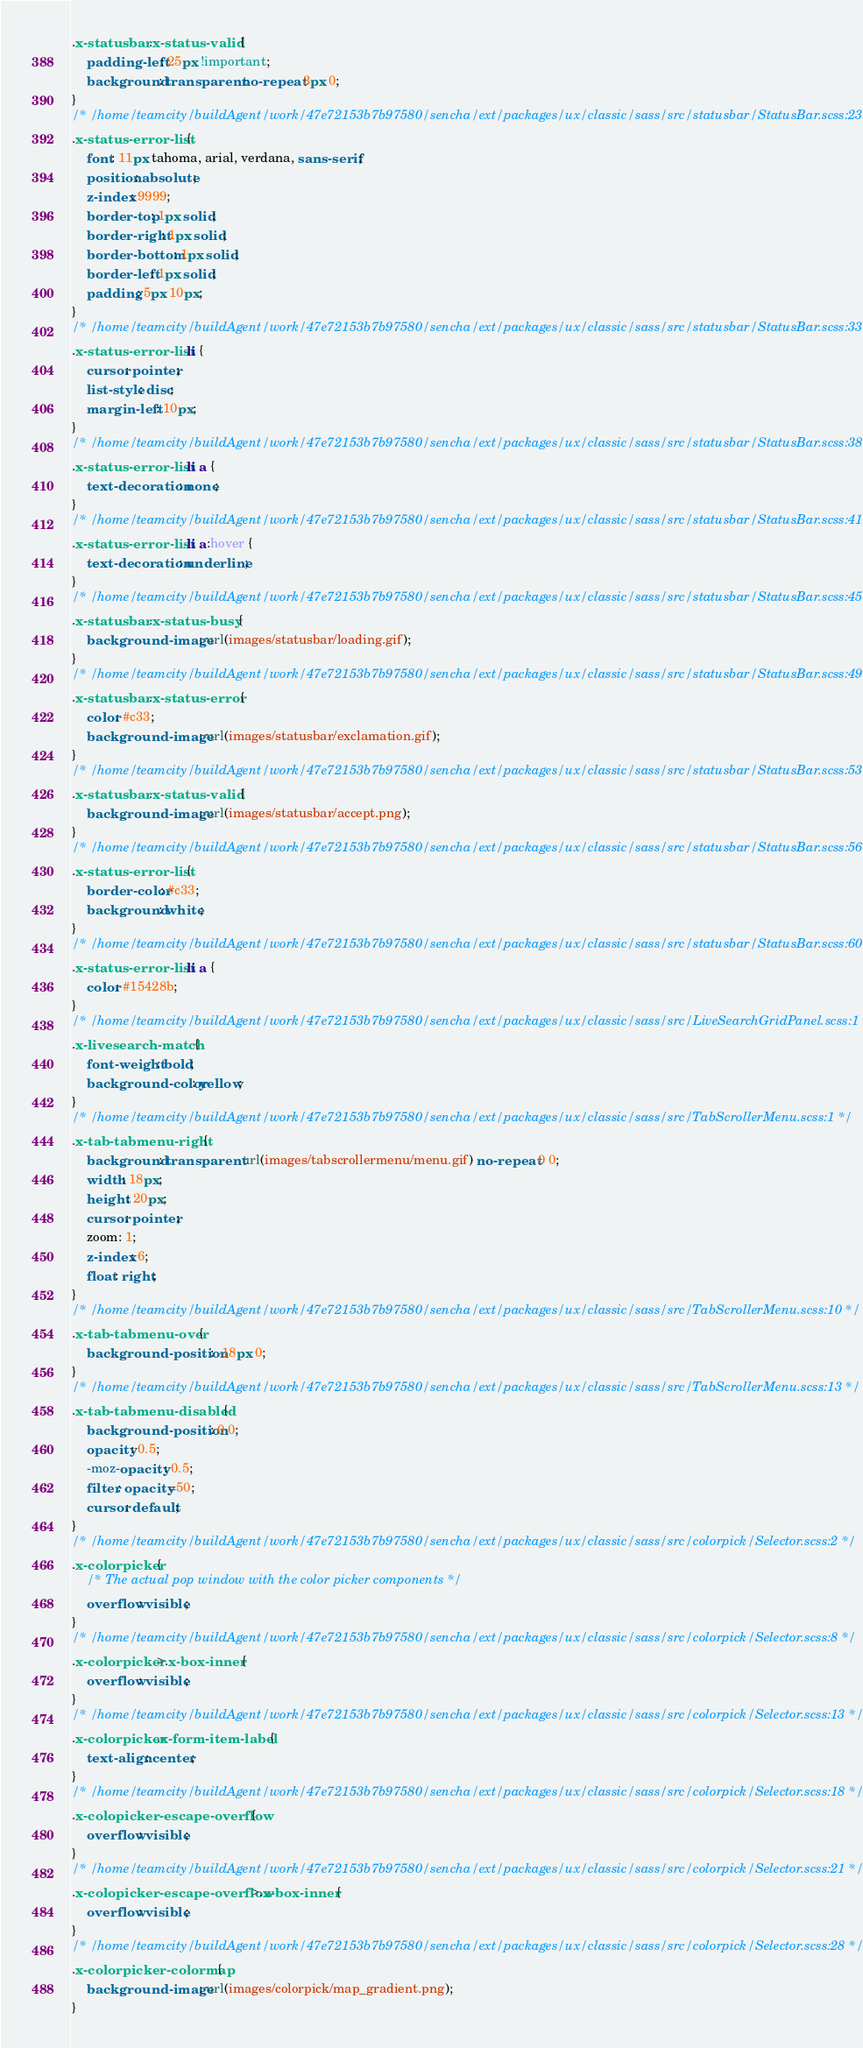<code> <loc_0><loc_0><loc_500><loc_500><_CSS_>.x-statusbar .x-status-valid {
    padding-left: 25px !important;
    background: transparent no-repeat 3px 0;
}
/* /home/teamcity/buildAgent/work/47e72153b7b97580/sencha/ext/packages/ux/classic/sass/src/statusbar/StatusBar.scss:23 */
.x-status-error-list {
    font: 11px tahoma, arial, verdana, sans-serif;
    position: absolute;
    z-index: 9999;
    border-top: 1px solid;
    border-right: 1px solid;
    border-bottom: 1px solid;
    border-left: 1px solid;
    padding: 5px 10px;
}
/* /home/teamcity/buildAgent/work/47e72153b7b97580/sencha/ext/packages/ux/classic/sass/src/statusbar/StatusBar.scss:33 */
.x-status-error-list li {
    cursor: pointer;
    list-style: disc;
    margin-left: 10px;
}
/* /home/teamcity/buildAgent/work/47e72153b7b97580/sencha/ext/packages/ux/classic/sass/src/statusbar/StatusBar.scss:38 */
.x-status-error-list li a {
    text-decoration: none;
}
/* /home/teamcity/buildAgent/work/47e72153b7b97580/sencha/ext/packages/ux/classic/sass/src/statusbar/StatusBar.scss:41 */
.x-status-error-list li a:hover {
    text-decoration: underline;
}
/* /home/teamcity/buildAgent/work/47e72153b7b97580/sencha/ext/packages/ux/classic/sass/src/statusbar/StatusBar.scss:45 */
.x-statusbar .x-status-busy {
    background-image: url(images/statusbar/loading.gif);
}
/* /home/teamcity/buildAgent/work/47e72153b7b97580/sencha/ext/packages/ux/classic/sass/src/statusbar/StatusBar.scss:49 */
.x-statusbar .x-status-error {
    color: #c33;
    background-image: url(images/statusbar/exclamation.gif);
}
/* /home/teamcity/buildAgent/work/47e72153b7b97580/sencha/ext/packages/ux/classic/sass/src/statusbar/StatusBar.scss:53 */
.x-statusbar .x-status-valid {
    background-image: url(images/statusbar/accept.png);
}
/* /home/teamcity/buildAgent/work/47e72153b7b97580/sencha/ext/packages/ux/classic/sass/src/statusbar/StatusBar.scss:56 */
.x-status-error-list {
    border-color: #c33;
    background: white;
}
/* /home/teamcity/buildAgent/work/47e72153b7b97580/sencha/ext/packages/ux/classic/sass/src/statusbar/StatusBar.scss:60 */
.x-status-error-list li a {
    color: #15428b;
}
/* /home/teamcity/buildAgent/work/47e72153b7b97580/sencha/ext/packages/ux/classic/sass/src/LiveSearchGridPanel.scss:1 */
.x-livesearch-match {
    font-weight: bold;
    background-color: yellow;
}
/* /home/teamcity/buildAgent/work/47e72153b7b97580/sencha/ext/packages/ux/classic/sass/src/TabScrollerMenu.scss:1 */
.x-tab-tabmenu-right {
    background: transparent url(images/tabscrollermenu/menu.gif) no-repeat 0 0;
    width: 18px;
    height: 20px;
    cursor: pointer;
    zoom: 1;
    z-index: 6;
    float: right;
}
/* /home/teamcity/buildAgent/work/47e72153b7b97580/sencha/ext/packages/ux/classic/sass/src/TabScrollerMenu.scss:10 */
.x-tab-tabmenu-over {
    background-position: -18px 0;
}
/* /home/teamcity/buildAgent/work/47e72153b7b97580/sencha/ext/packages/ux/classic/sass/src/TabScrollerMenu.scss:13 */
.x-tab-tabmenu-disabled {
    background-position: 0 0;
    opacity: 0.5;
    -moz-opacity: 0.5;
    filter: opacity=50;
    cursor: default;
}
/* /home/teamcity/buildAgent/work/47e72153b7b97580/sencha/ext/packages/ux/classic/sass/src/colorpick/Selector.scss:2 */
.x-colorpicker {
    /* The actual pop window with the color picker components */
    overflow: visible;
}
/* /home/teamcity/buildAgent/work/47e72153b7b97580/sencha/ext/packages/ux/classic/sass/src/colorpick/Selector.scss:8 */
.x-colorpicker >.x-box-inner {
    overflow: visible;
}
/* /home/teamcity/buildAgent/work/47e72153b7b97580/sencha/ext/packages/ux/classic/sass/src/colorpick/Selector.scss:13 */
.x-colorpicker .x-form-item-label {
    text-align: center;
}
/* /home/teamcity/buildAgent/work/47e72153b7b97580/sencha/ext/packages/ux/classic/sass/src/colorpick/Selector.scss:18 */
.x-colopicker-escape-overflow {
    overflow: visible;
}
/* /home/teamcity/buildAgent/work/47e72153b7b97580/sencha/ext/packages/ux/classic/sass/src/colorpick/Selector.scss:21 */
.x-colopicker-escape-overflow >.x-box-inner {
    overflow: visible;
}
/* /home/teamcity/buildAgent/work/47e72153b7b97580/sencha/ext/packages/ux/classic/sass/src/colorpick/Selector.scss:28 */
.x-colorpicker-colormap {
    background-image: url(images/colorpick/map_gradient.png);
}</code> 